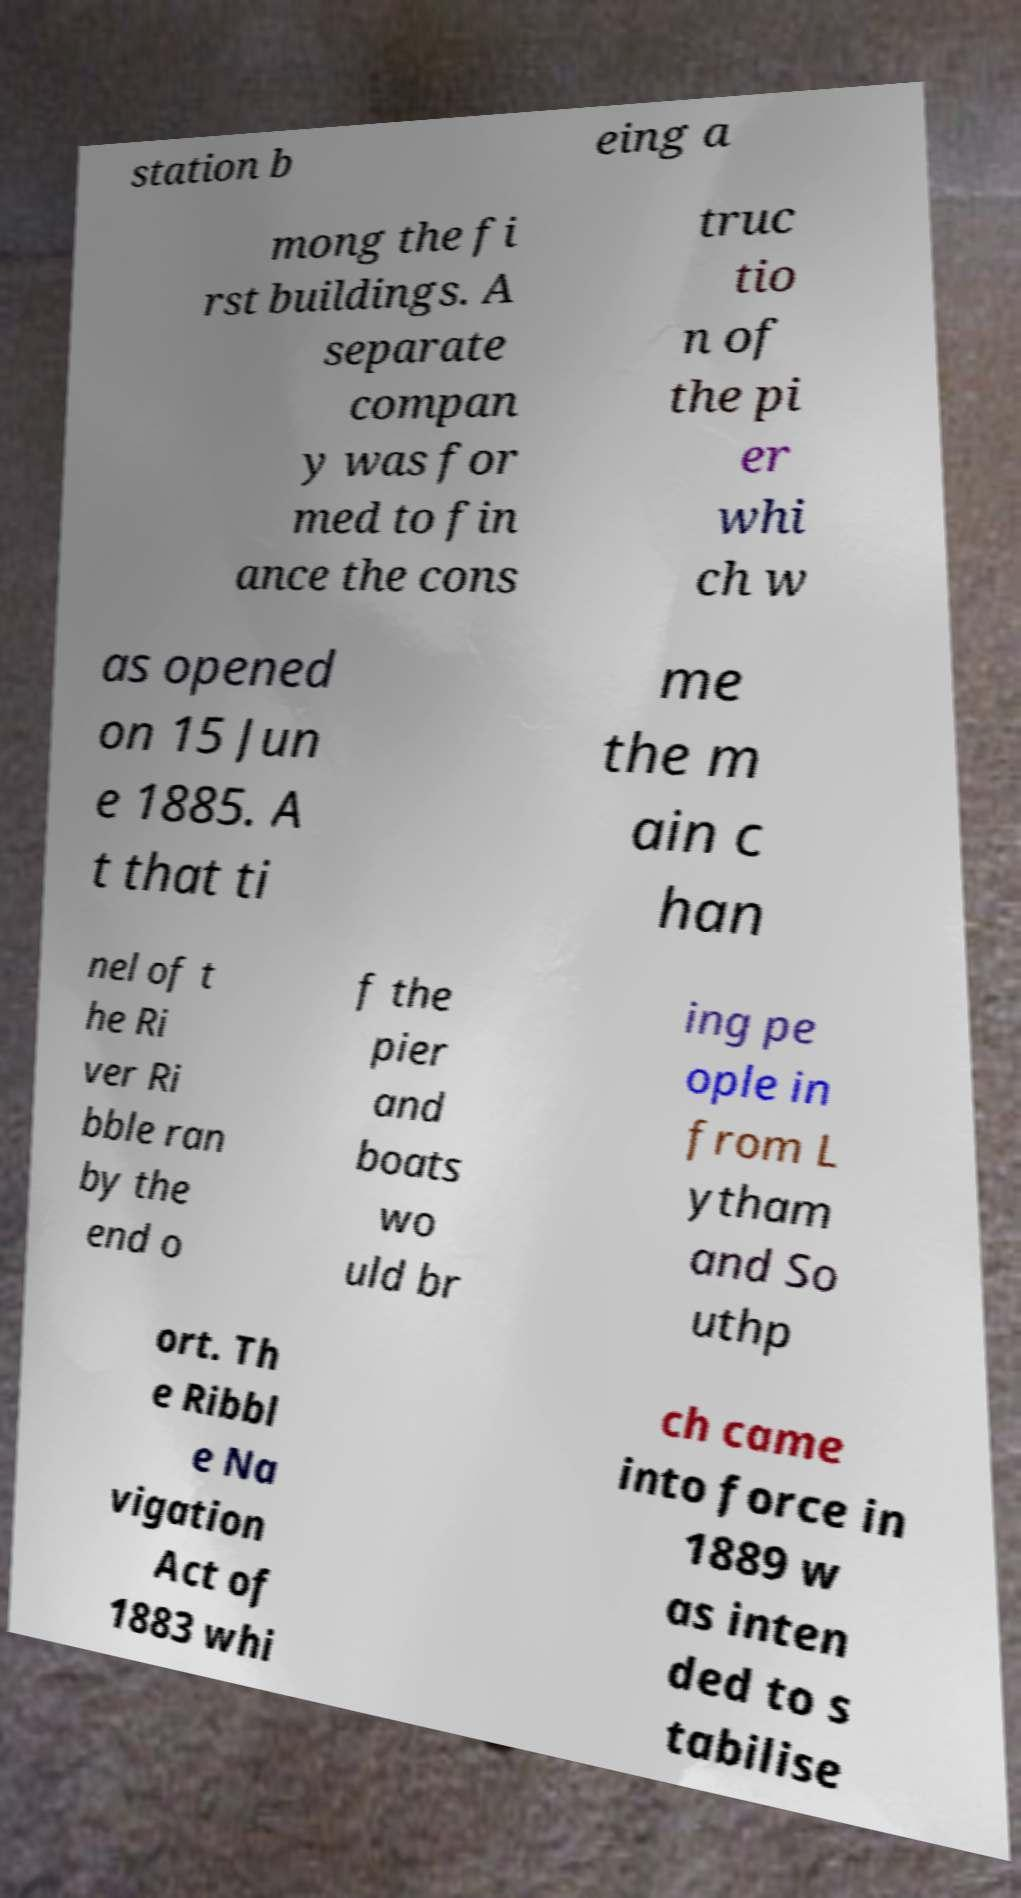Can you read and provide the text displayed in the image?This photo seems to have some interesting text. Can you extract and type it out for me? station b eing a mong the fi rst buildings. A separate compan y was for med to fin ance the cons truc tio n of the pi er whi ch w as opened on 15 Jun e 1885. A t that ti me the m ain c han nel of t he Ri ver Ri bble ran by the end o f the pier and boats wo uld br ing pe ople in from L ytham and So uthp ort. Th e Ribbl e Na vigation Act of 1883 whi ch came into force in 1889 w as inten ded to s tabilise 